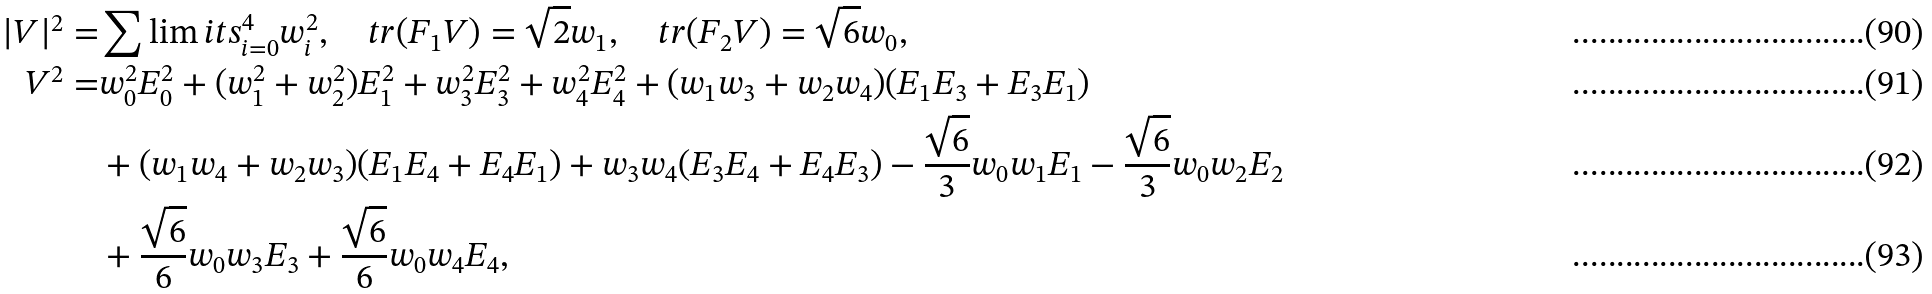<formula> <loc_0><loc_0><loc_500><loc_500>| V | ^ { 2 } = & \sum \lim i t s _ { i = 0 } ^ { 4 } w _ { i } ^ { 2 } , \quad t r ( F _ { 1 } V ) = \sqrt { 2 } w _ { 1 } , \quad t r ( F _ { 2 } V ) = \sqrt { 6 } w _ { 0 } , \\ V ^ { 2 } = & w _ { 0 } ^ { 2 } E _ { 0 } ^ { 2 } + ( w _ { 1 } ^ { 2 } + w _ { 2 } ^ { 2 } ) E _ { 1 } ^ { 2 } + w _ { 3 } ^ { 2 } E _ { 3 } ^ { 2 } + w _ { 4 } ^ { 2 } E _ { 4 } ^ { 2 } + ( w _ { 1 } w _ { 3 } + w _ { 2 } w _ { 4 } ) ( E _ { 1 } E _ { 3 } + E _ { 3 } E _ { 1 } ) \\ & + ( w _ { 1 } w _ { 4 } + w _ { 2 } w _ { 3 } ) ( E _ { 1 } E _ { 4 } + E _ { 4 } E _ { 1 } ) + w _ { 3 } w _ { 4 } ( E _ { 3 } E _ { 4 } + E _ { 4 } E _ { 3 } ) - \frac { \sqrt { 6 } } { 3 } w _ { 0 } w _ { 1 } E _ { 1 } - \frac { \sqrt { 6 } } { 3 } w _ { 0 } w _ { 2 } E _ { 2 } \\ & + \frac { \sqrt { 6 } } { 6 } w _ { 0 } w _ { 3 } E _ { 3 } + \frac { \sqrt { 6 } } { 6 } w _ { 0 } w _ { 4 } E _ { 4 } ,</formula> 